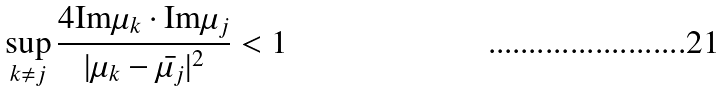Convert formula to latex. <formula><loc_0><loc_0><loc_500><loc_500>\sup _ { k \neq j } \frac { 4 \text {Im} \mu _ { k } \cdot \text {Im} \mu _ { j } } { | \mu _ { k } - \bar { \mu _ { j } } | ^ { 2 } } < 1</formula> 